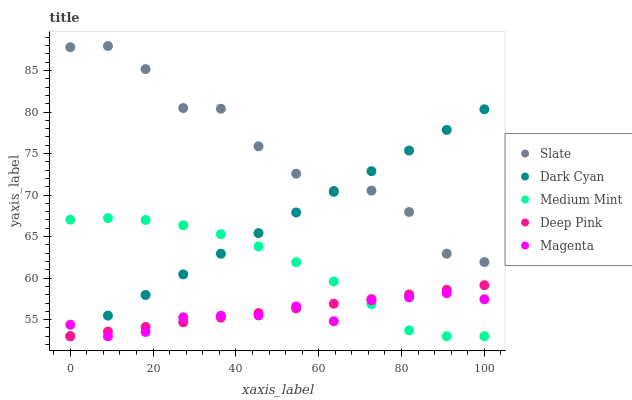Does Magenta have the minimum area under the curve?
Answer yes or no. Yes. Does Slate have the maximum area under the curve?
Answer yes or no. Yes. Does Medium Mint have the minimum area under the curve?
Answer yes or no. No. Does Medium Mint have the maximum area under the curve?
Answer yes or no. No. Is Deep Pink the smoothest?
Answer yes or no. Yes. Is Slate the roughest?
Answer yes or no. Yes. Is Medium Mint the smoothest?
Answer yes or no. No. Is Medium Mint the roughest?
Answer yes or no. No. Does Dark Cyan have the lowest value?
Answer yes or no. Yes. Does Slate have the lowest value?
Answer yes or no. No. Does Slate have the highest value?
Answer yes or no. Yes. Does Medium Mint have the highest value?
Answer yes or no. No. Is Deep Pink less than Slate?
Answer yes or no. Yes. Is Slate greater than Medium Mint?
Answer yes or no. Yes. Does Deep Pink intersect Dark Cyan?
Answer yes or no. Yes. Is Deep Pink less than Dark Cyan?
Answer yes or no. No. Is Deep Pink greater than Dark Cyan?
Answer yes or no. No. Does Deep Pink intersect Slate?
Answer yes or no. No. 